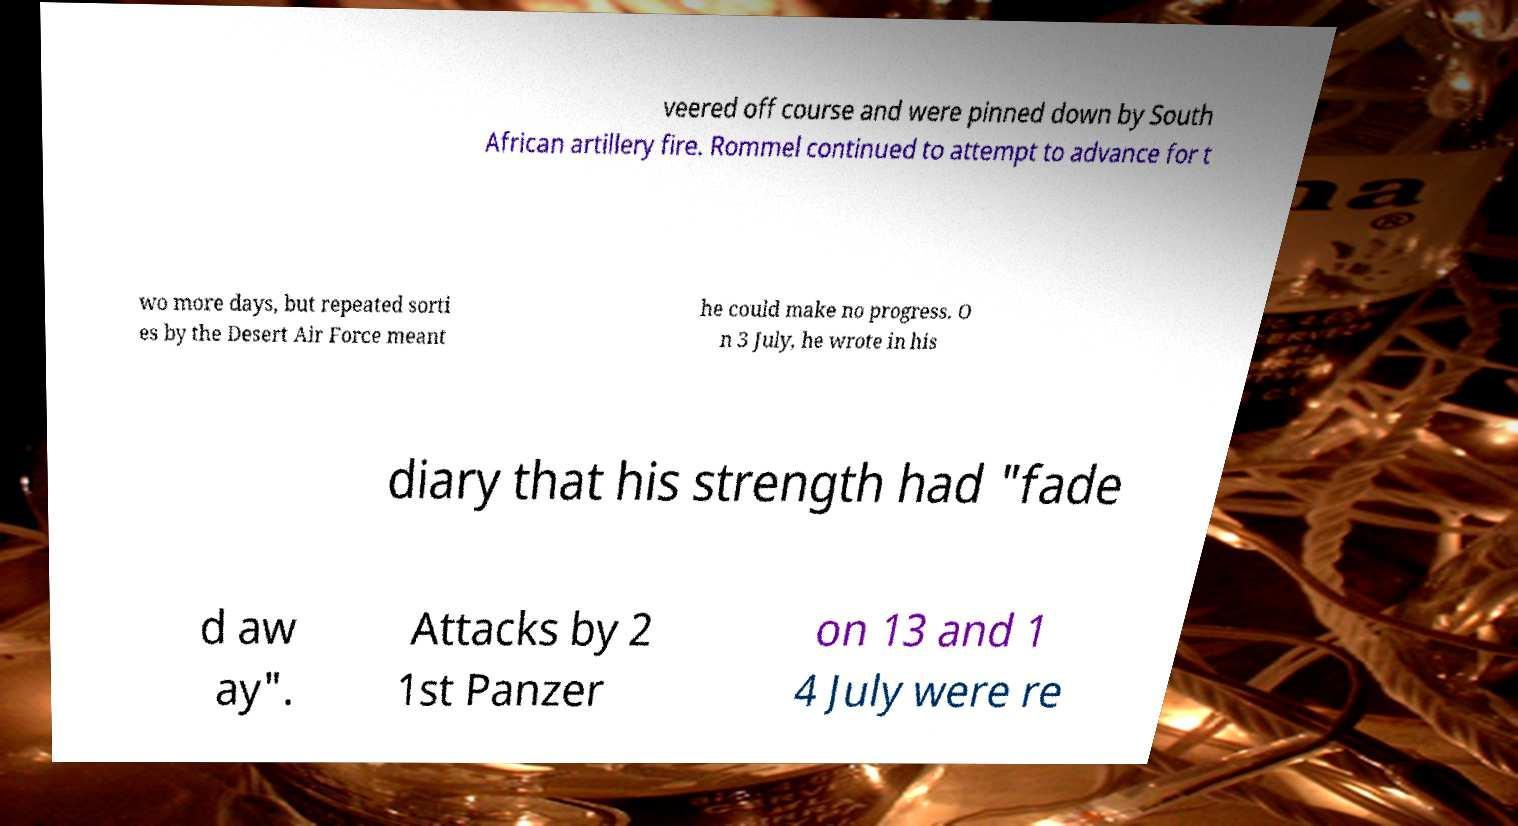For documentation purposes, I need the text within this image transcribed. Could you provide that? veered off course and were pinned down by South African artillery fire. Rommel continued to attempt to advance for t wo more days, but repeated sorti es by the Desert Air Force meant he could make no progress. O n 3 July, he wrote in his diary that his strength had "fade d aw ay". Attacks by 2 1st Panzer on 13 and 1 4 July were re 